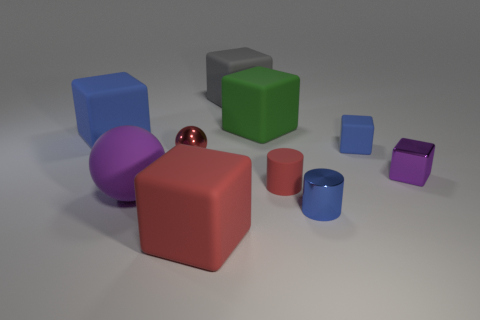There is a red rubber object that is on the right side of the big green cube; what is its size?
Make the answer very short. Small. What number of things are large blue blocks or red objects behind the blue cylinder?
Ensure brevity in your answer.  3. There is a small red thing that is the same shape as the purple rubber object; what is its material?
Make the answer very short. Metal. Is the number of small red cylinders to the right of the red rubber cylinder greater than the number of large cyan cubes?
Offer a very short reply. No. Is there any other thing of the same color as the metallic ball?
Offer a terse response. Yes. What is the shape of the small blue thing that is made of the same material as the tiny purple block?
Give a very brief answer. Cylinder. Do the blue object that is on the left side of the green cube and the red block have the same material?
Provide a short and direct response. Yes. What is the shape of the large thing that is the same color as the tiny metal ball?
Offer a terse response. Cube. There is a metal object to the left of the big green cube; does it have the same color as the large object right of the big gray matte thing?
Give a very brief answer. No. How many large things are in front of the big blue cube and right of the large gray thing?
Make the answer very short. 0. 